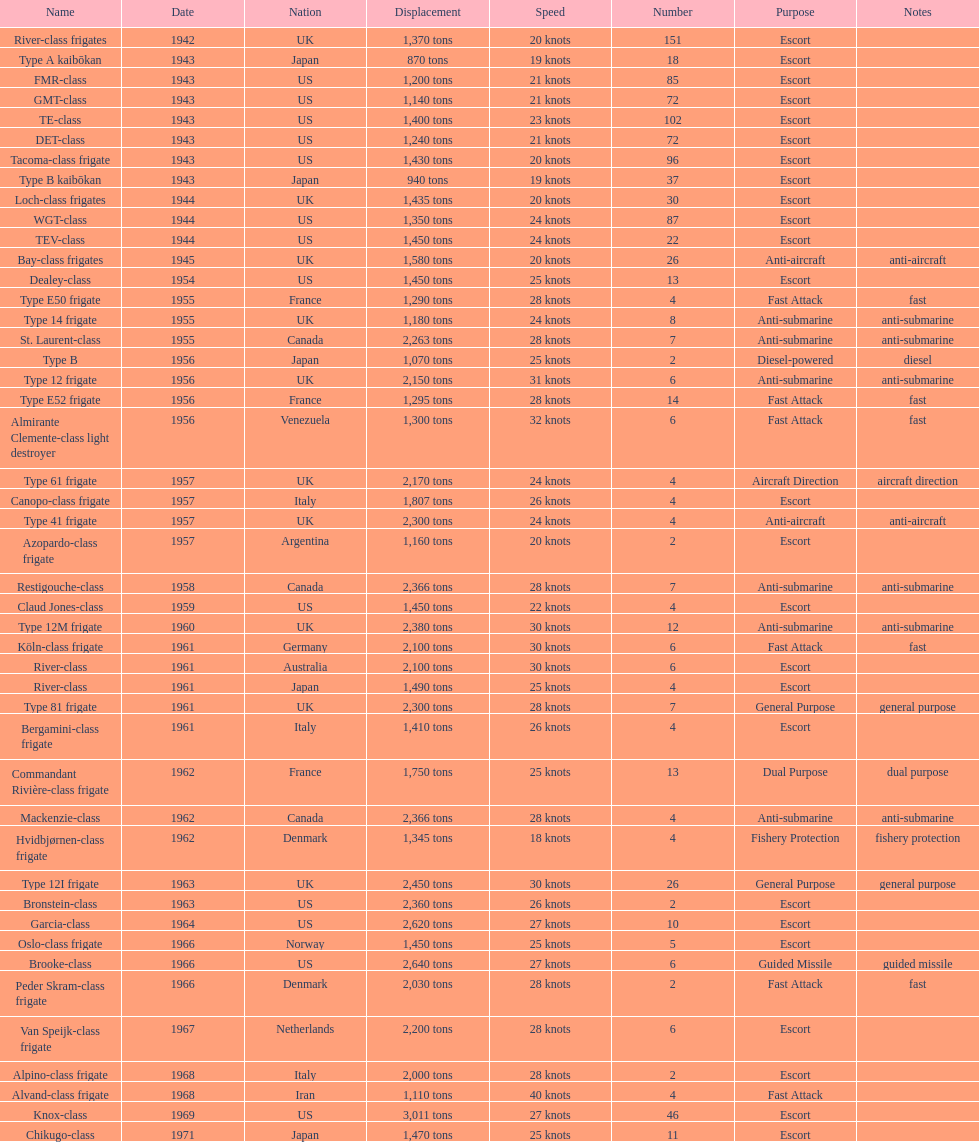How many tons of displacement does type b have? 940 tons. 